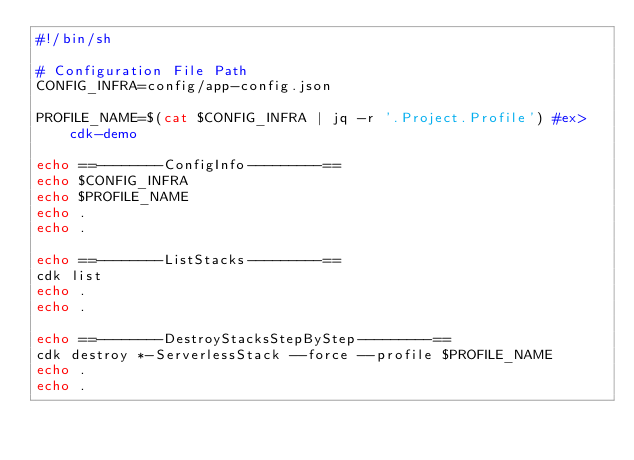<code> <loc_0><loc_0><loc_500><loc_500><_Bash_>#!/bin/sh

# Configuration File Path
CONFIG_INFRA=config/app-config.json

PROFILE_NAME=$(cat $CONFIG_INFRA | jq -r '.Project.Profile') #ex> cdk-demo

echo ==--------ConfigInfo---------==
echo $CONFIG_INFRA
echo $PROFILE_NAME
echo .
echo .

echo ==--------ListStacks---------==
cdk list
echo .
echo .

echo ==--------DestroyStacksStepByStep---------==
cdk destroy *-ServerlessStack --force --profile $PROFILE_NAME
echo .
echo .
</code> 